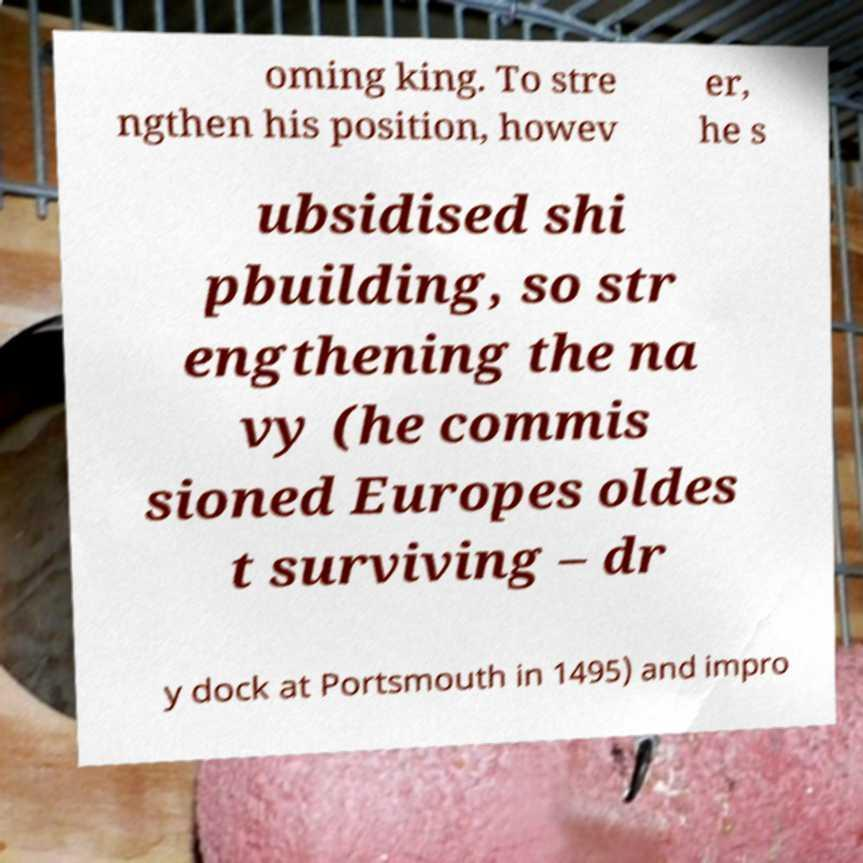What messages or text are displayed in this image? I need them in a readable, typed format. oming king. To stre ngthen his position, howev er, he s ubsidised shi pbuilding, so str engthening the na vy (he commis sioned Europes oldes t surviving – dr y dock at Portsmouth in 1495) and impro 